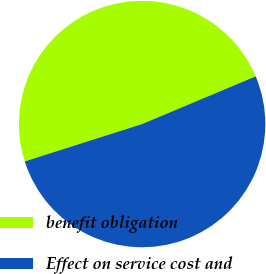<chart> <loc_0><loc_0><loc_500><loc_500><pie_chart><fcel>benefit obligation<fcel>Effect on service cost and<nl><fcel>48.58%<fcel>51.42%<nl></chart> 